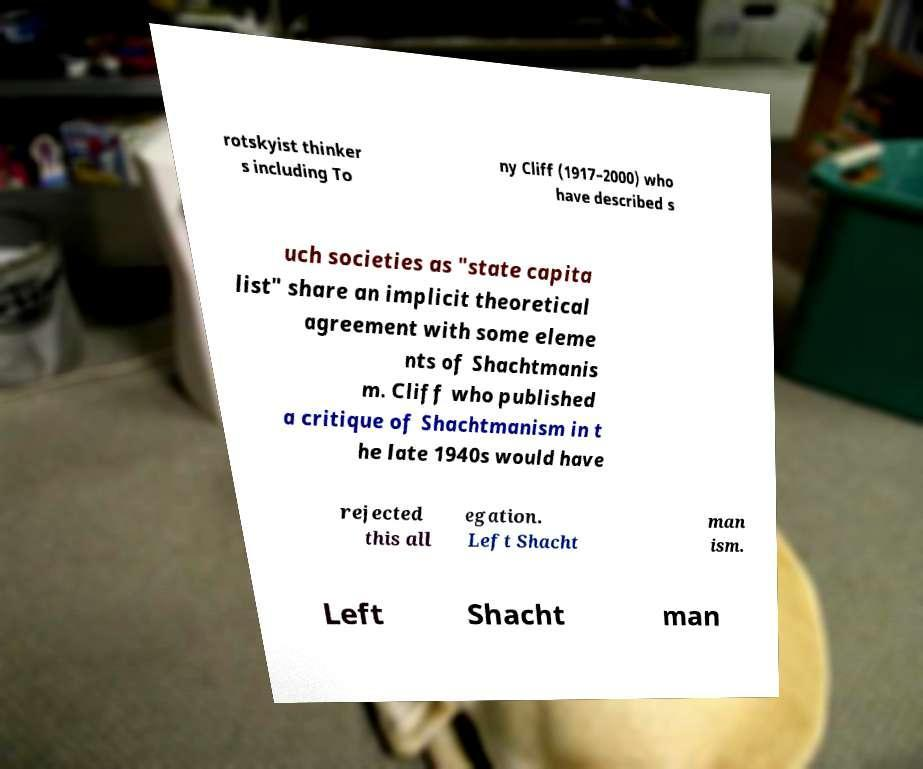There's text embedded in this image that I need extracted. Can you transcribe it verbatim? rotskyist thinker s including To ny Cliff (1917–2000) who have described s uch societies as "state capita list" share an implicit theoretical agreement with some eleme nts of Shachtmanis m. Cliff who published a critique of Shachtmanism in t he late 1940s would have rejected this all egation. Left Shacht man ism. Left Shacht man 